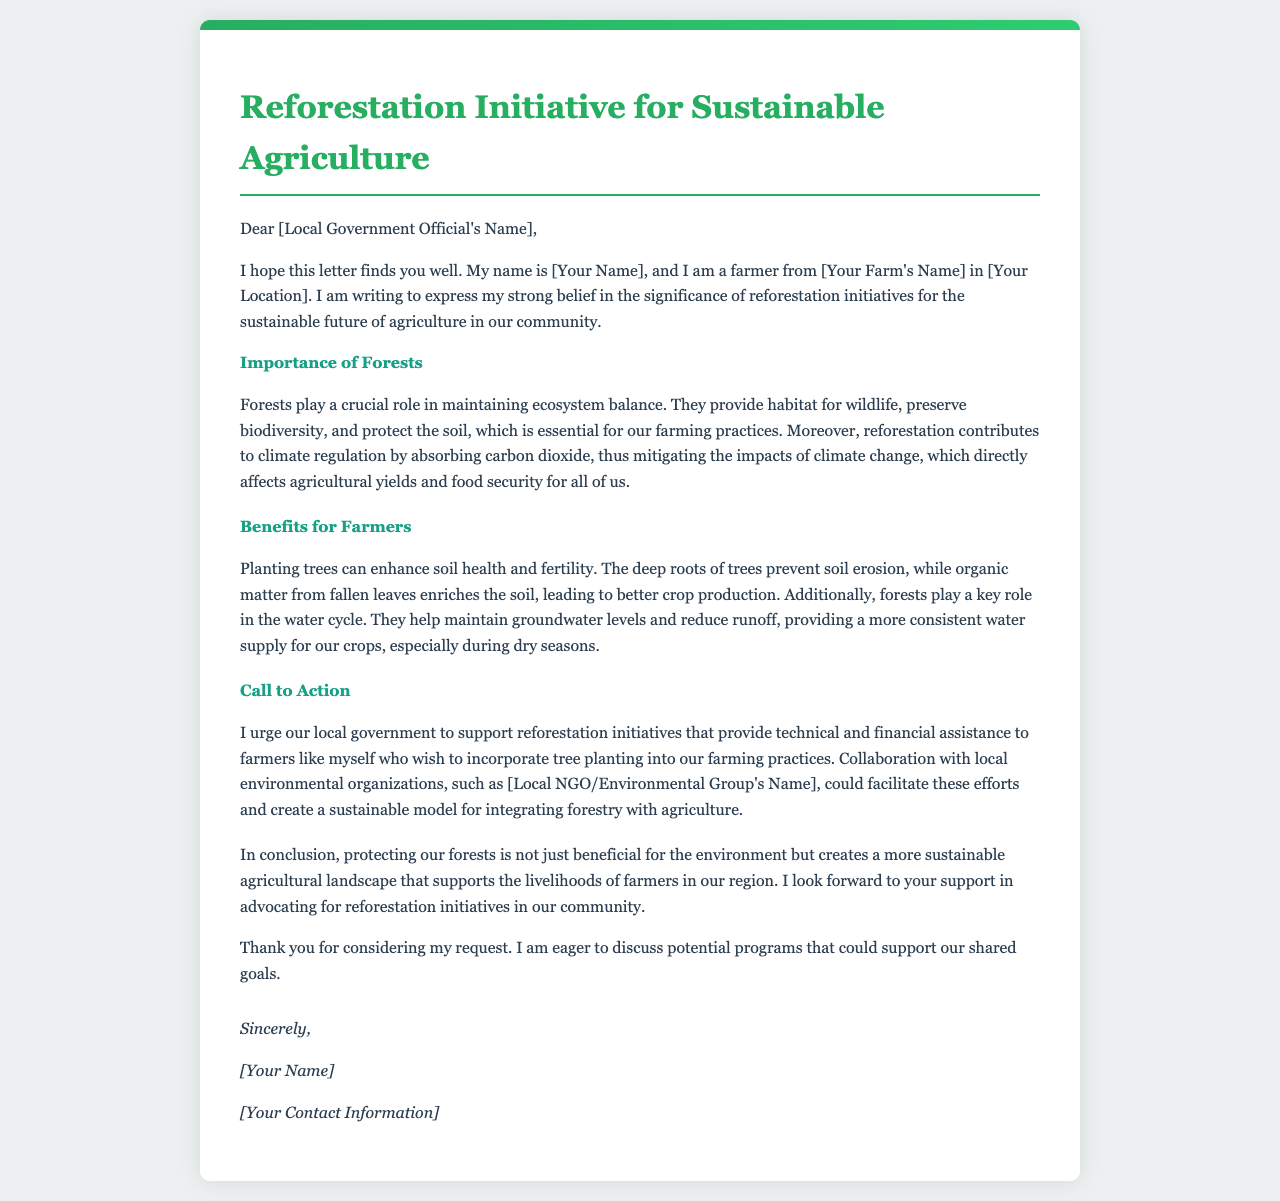What is the title of the letter? The title of the letter describes the main topic addressed in the document, which is focused on reforestation initiatives relevant to agriculture.
Answer: Reforestation Initiative for Sustainable Agriculture Who is the sender of the letter? The letter contains a placeholder for the sender’s name, which indicates the identity of the farmer writing the letter.
Answer: [Your Name] What is one benefit of reforestation mentioned in the letter? The letter specifies benefits that trees provide to farming practices, including soil health and water supply.
Answer: Soil health Which local organizations are suggested for collaboration in the letter? The letter suggests that the local government should partner with environmental organizations to enhance reforestation efforts.
Answer: [Local NGO/Environmental Group's Name] What action does the letter urge the local government to take? The urgent request directed at the local government focuses on support for specific initiatives that assist farmers.
Answer: Support reforestation initiatives What is the significance of forests mentioned in the letter? The letter outlines multiple roles of forests, especially emphasizing the ecological balance they help maintain.
Answer: Ecosystem balance In what context are farmers mentioned in the letter? Farmers are discussed in relation to how reforestation initiatives can enhance their agricultural practices and livelihoods.
Answer: Enhancing agricultural practices What should the local government consider according to the letter? The letter expresses a call to action for the government to recognize the importance of trees for sustaining agriculture.
Answer: Supporting reforestation initiatives What is the conclusion's main message in the letter? The conclusion emphasizes the broader importance of forest protection for sustainability in agriculture and farmer livelihoods.
Answer: Protecting our forests is essential for sustainable agriculture 